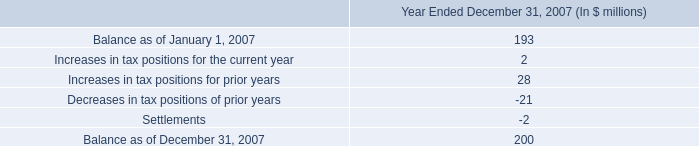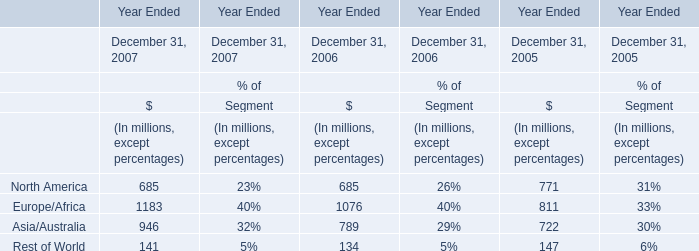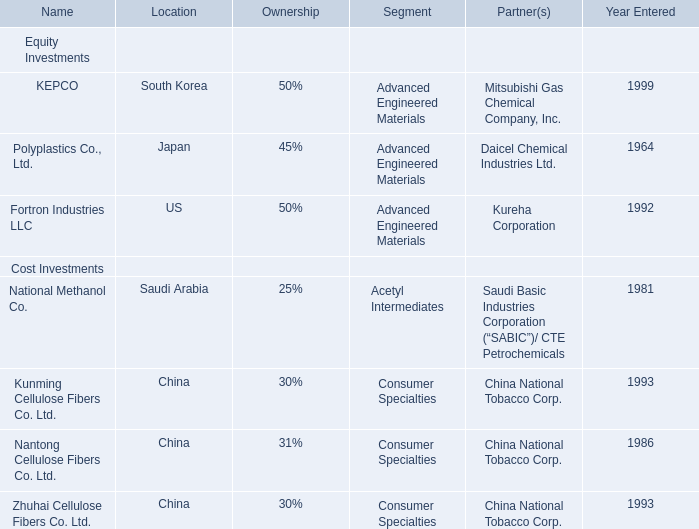what is the percent of interest and penalties as part of the unrecognized tax benefits as of december 312007 
Computations: (36 / 2000)
Answer: 0.018. What is the row number of the area with percentage proportion greater than 35% in 2007? 
Answer: 6. 